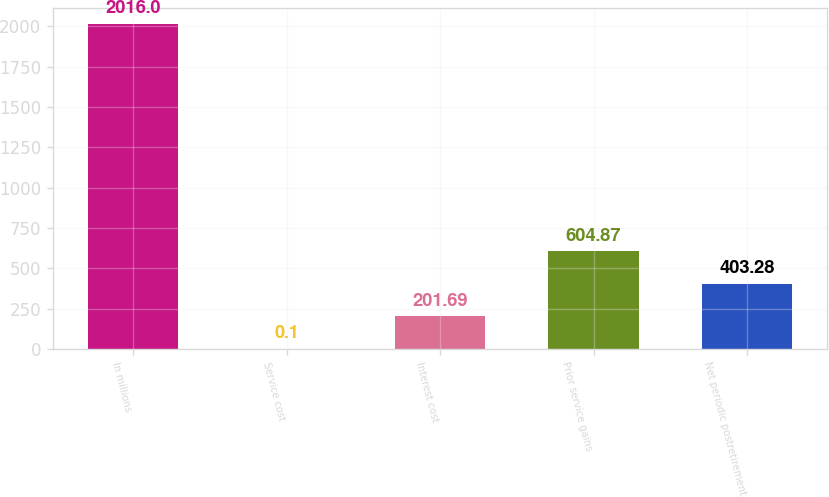Convert chart. <chart><loc_0><loc_0><loc_500><loc_500><bar_chart><fcel>In millions<fcel>Service cost<fcel>Interest cost<fcel>Prior service gains<fcel>Net periodic postretirement<nl><fcel>2016<fcel>0.1<fcel>201.69<fcel>604.87<fcel>403.28<nl></chart> 